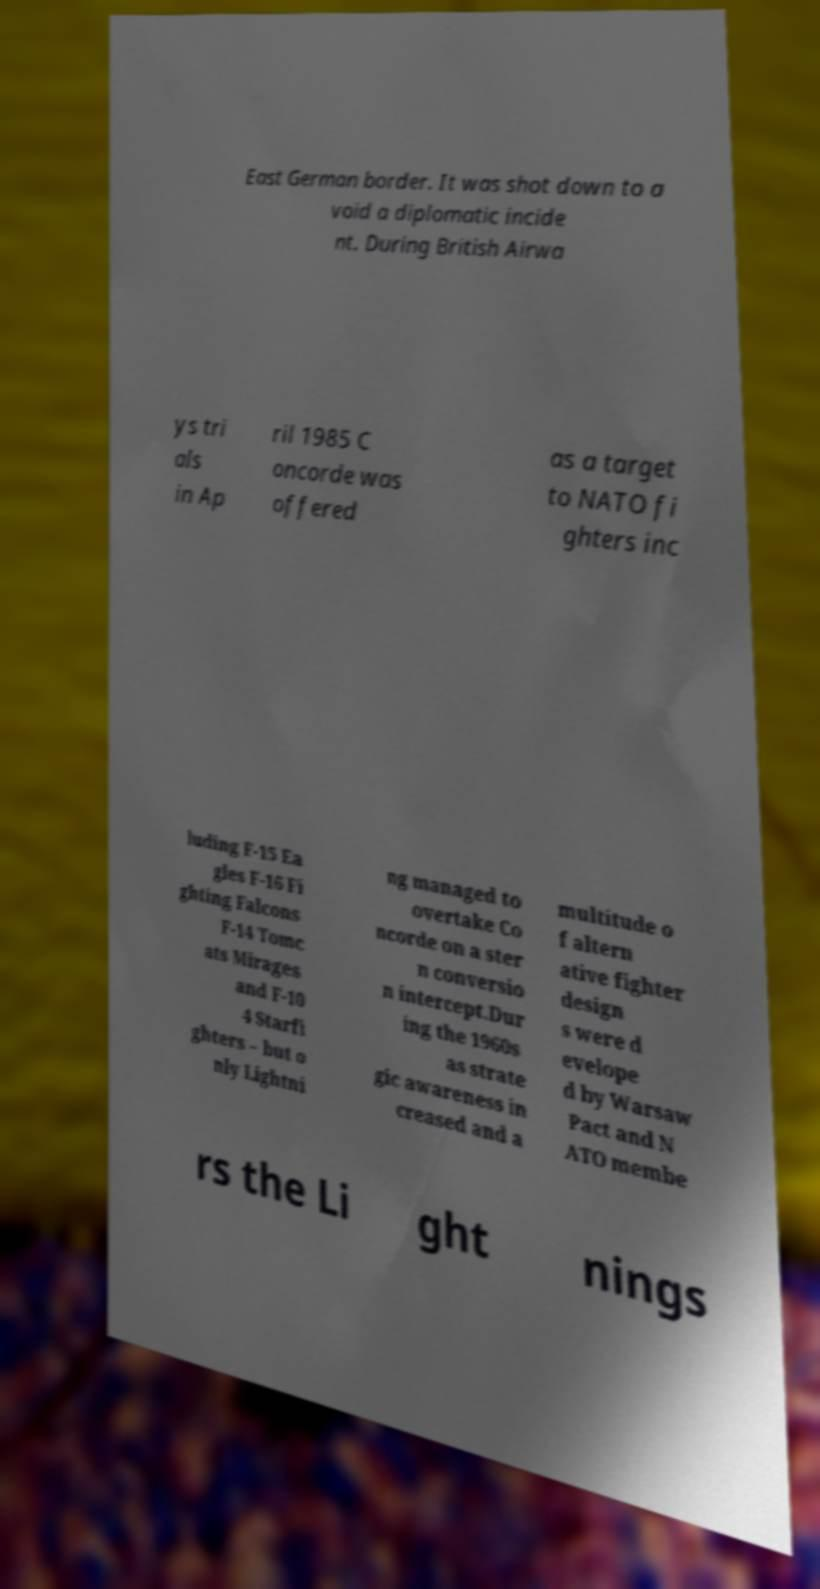Can you accurately transcribe the text from the provided image for me? East German border. It was shot down to a void a diplomatic incide nt. During British Airwa ys tri als in Ap ril 1985 C oncorde was offered as a target to NATO fi ghters inc luding F-15 Ea gles F-16 Fi ghting Falcons F-14 Tomc ats Mirages and F-10 4 Starfi ghters – but o nly Lightni ng managed to overtake Co ncorde on a ster n conversio n intercept.Dur ing the 1960s as strate gic awareness in creased and a multitude o f altern ative fighter design s were d evelope d by Warsaw Pact and N ATO membe rs the Li ght nings 